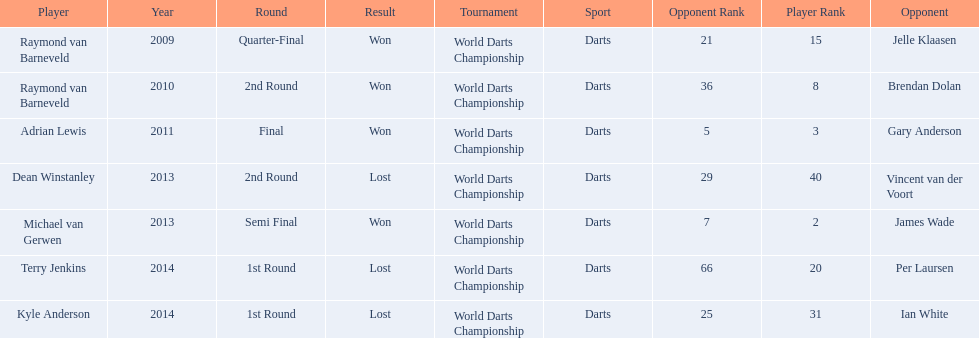What are all the years? 2009, 2010, 2011, 2013, 2013, 2014, 2014. Of these, which ones are 2014? 2014, 2014. Of these dates which one is associated with a player other than kyle anderson? 2014. What is the player name associated with this year? Terry Jenkins. 